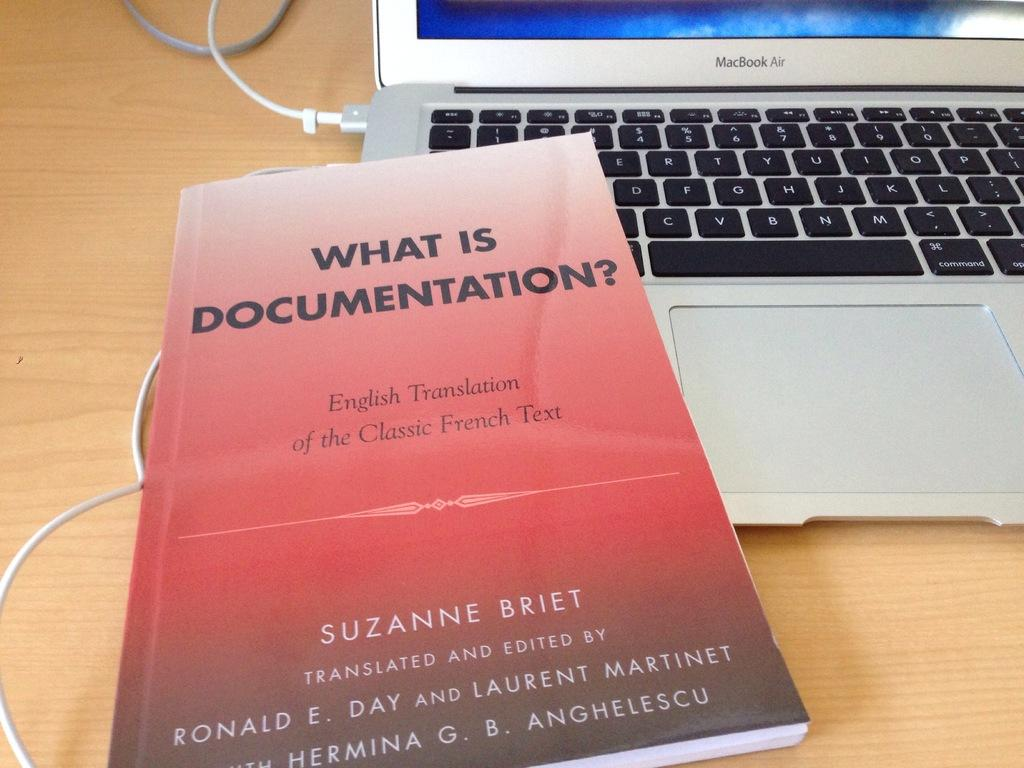Provide a one-sentence caption for the provided image. Red book titled "What is Documentation" on top of a silver laptop. 